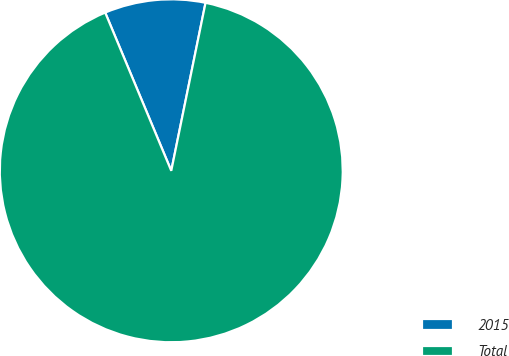Convert chart to OTSL. <chart><loc_0><loc_0><loc_500><loc_500><pie_chart><fcel>2015<fcel>Total<nl><fcel>9.5%<fcel>90.5%<nl></chart> 